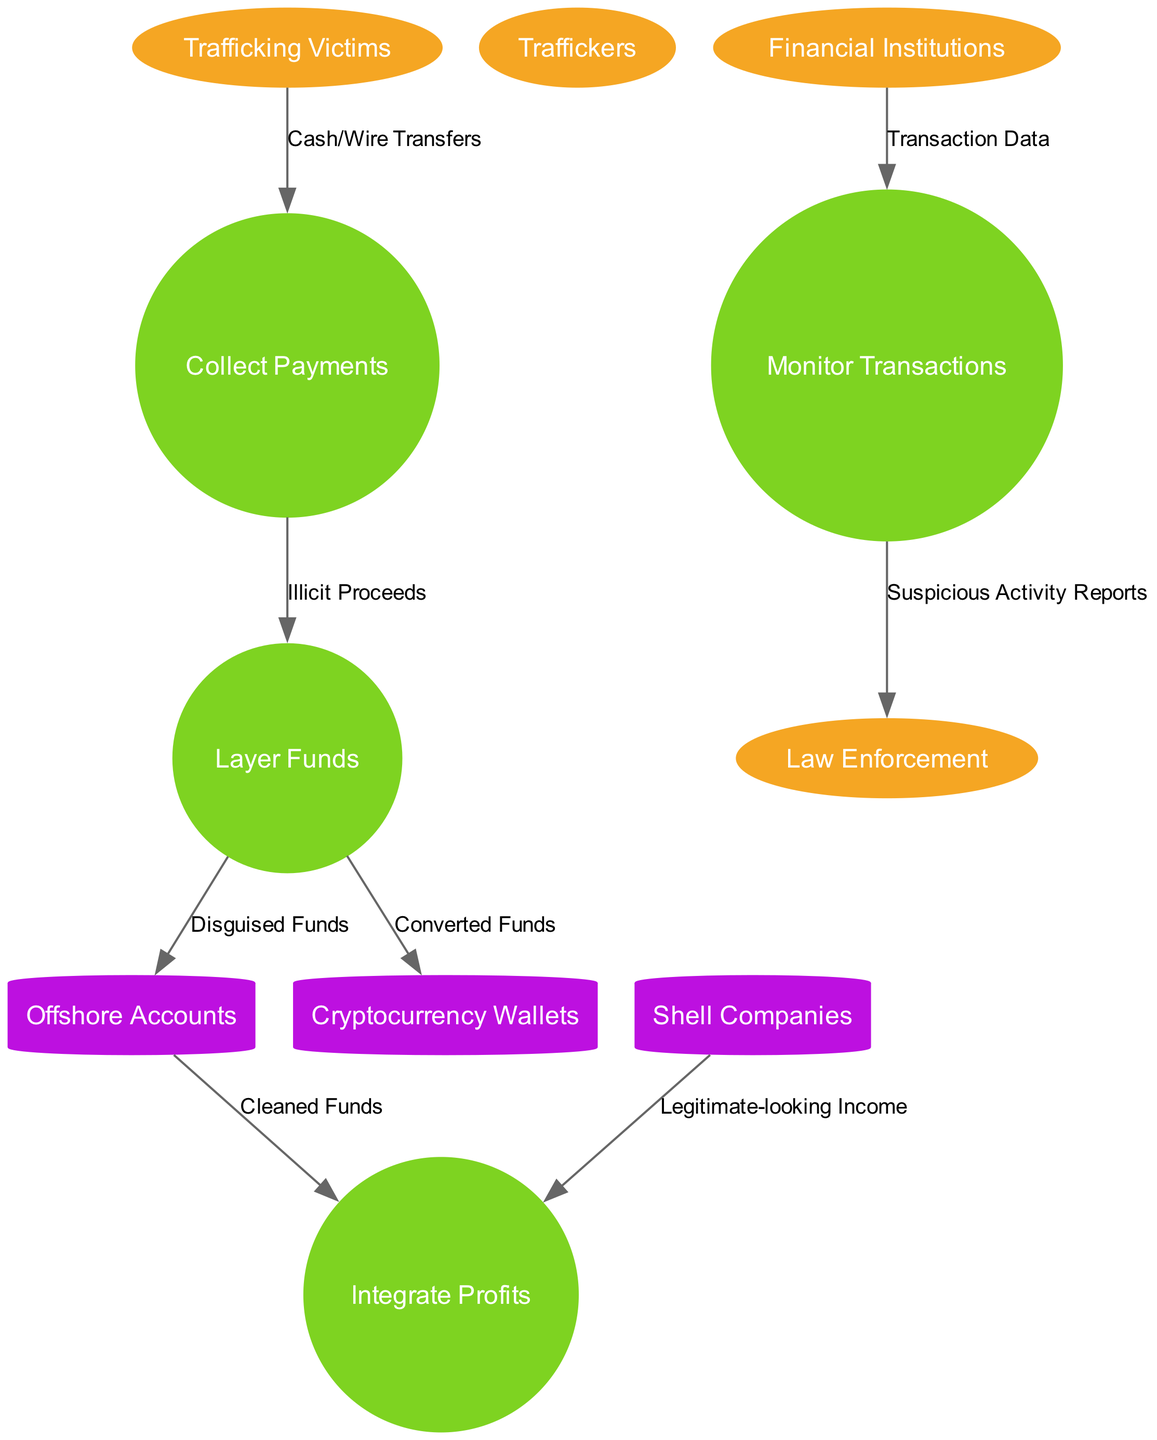What are the external entities represented in the diagram? The external entities include Trafficking Victims, Traffickers, Financial Institutions, and Law Enforcement. By identifying the labeled ellipses in the diagram, these four distinct external parties can be noted.
Answer: Trafficking Victims, Traffickers, Financial Institutions, Law Enforcement How many processes are illustrated in the diagram? The diagram includes four processes: Collect Payments, Layer Funds, Integrate Profits, and Monitor Transactions. Counting the circular nodes, we can see that there are four distinct processes.
Answer: 4 What type of data is transferred from Trafficking Victims to Collect Payments? The data transferred is labeled as Cash/Wire Transfers. Following the data flow from the external entity to the process allows us to identify the specific type of transaction involved.
Answer: Cash/Wire Transfers What data store is used to hold Disguised Funds? The data store designated for Disguised Funds is Offshore Accounts. By following the flow from Layer Funds to the Offshore Accounts, we can determine where the funds are stored.
Answer: Offshore Accounts Which external entity provides Transaction Data to Monitor Transactions? Financial Institutions provide Transaction Data to the process of Monitor Transactions. Observing the flow from Financial Institutions to Monitor Transactions shows this specific relationship.
Answer: Financial Institutions How many different data stores are depicted in the diagram? There are three data stores shown: Offshore Accounts, Shell Companies, and Cryptocurrency Wallets. Counting these distinct cylindrical nodes lets us conclude the total number of data stores.
Answer: 3 What indicates the flow of information to Law Enforcement in the diagram? The flow of Suspicious Activity Reports to Law Enforcement indicates this relationship. By tracing the flow from Monitor Transactions to Law Enforcement, we can identify the respective information shared.
Answer: Suspicious Activity Reports What type of income comes from Shell Companies to Integrate Profits? The income is labeled as Legitimate-looking Income. By following the data flow from Shell Companies to Integrate Profits, it shows how the appearance of legitimacy is achieved.
Answer: Legitimate-looking Income What is the purpose of the Layer Funds process in relation to the data flows? The purpose is to disguise illicit proceeds and convert them into clean funds. By analyzing the flows into Offshore Accounts and Cryptocurrency Wallets, we deduce that its role is to launder money.
Answer: Disguise illicit proceeds and convert into clean funds 